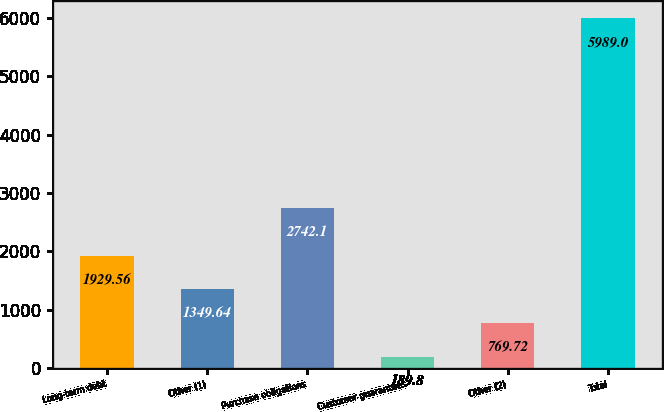<chart> <loc_0><loc_0><loc_500><loc_500><bar_chart><fcel>Long-term debt<fcel>Other (1)<fcel>Purchase obligations<fcel>Customer guarantees<fcel>Other (2)<fcel>Total<nl><fcel>1929.56<fcel>1349.64<fcel>2742.1<fcel>189.8<fcel>769.72<fcel>5989<nl></chart> 